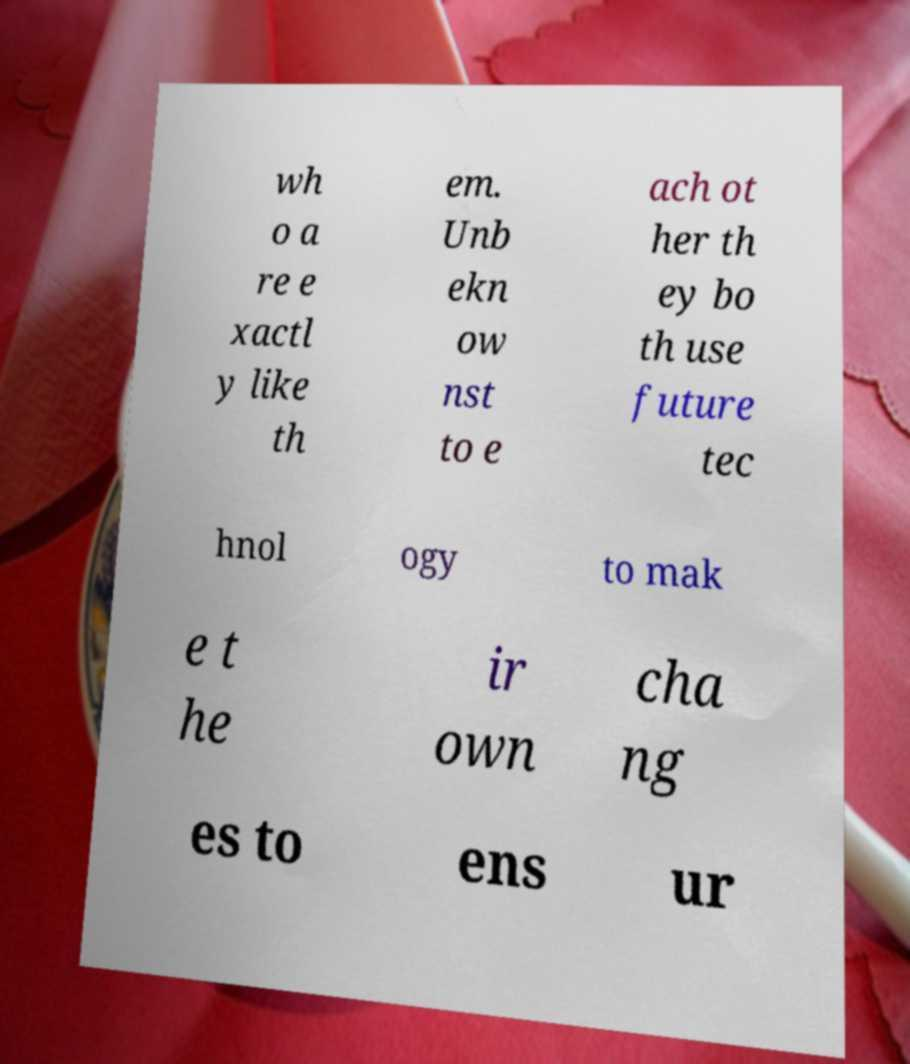Please read and relay the text visible in this image. What does it say? wh o a re e xactl y like th em. Unb ekn ow nst to e ach ot her th ey bo th use future tec hnol ogy to mak e t he ir own cha ng es to ens ur 